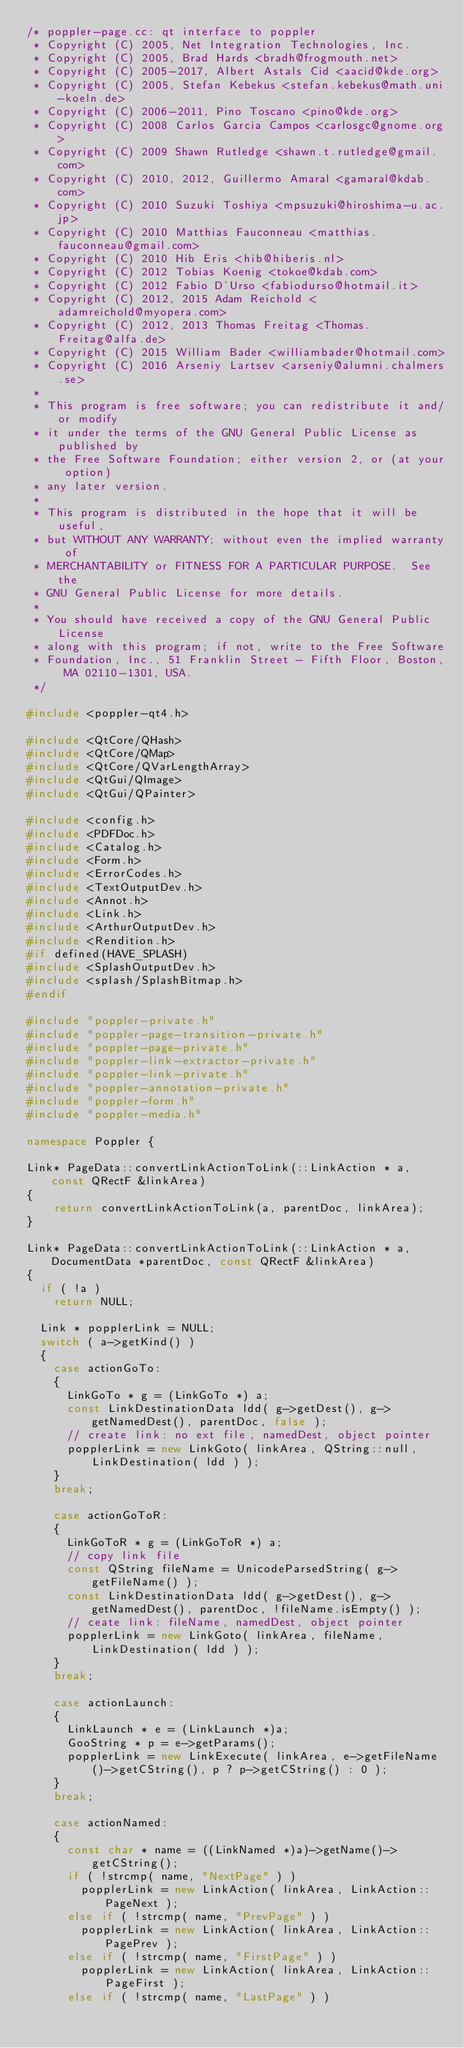Convert code to text. <code><loc_0><loc_0><loc_500><loc_500><_C++_>/* poppler-page.cc: qt interface to poppler
 * Copyright (C) 2005, Net Integration Technologies, Inc.
 * Copyright (C) 2005, Brad Hards <bradh@frogmouth.net>
 * Copyright (C) 2005-2017, Albert Astals Cid <aacid@kde.org>
 * Copyright (C) 2005, Stefan Kebekus <stefan.kebekus@math.uni-koeln.de>
 * Copyright (C) 2006-2011, Pino Toscano <pino@kde.org>
 * Copyright (C) 2008 Carlos Garcia Campos <carlosgc@gnome.org>
 * Copyright (C) 2009 Shawn Rutledge <shawn.t.rutledge@gmail.com>
 * Copyright (C) 2010, 2012, Guillermo Amaral <gamaral@kdab.com>
 * Copyright (C) 2010 Suzuki Toshiya <mpsuzuki@hiroshima-u.ac.jp>
 * Copyright (C) 2010 Matthias Fauconneau <matthias.fauconneau@gmail.com>
 * Copyright (C) 2010 Hib Eris <hib@hiberis.nl>
 * Copyright (C) 2012 Tobias Koenig <tokoe@kdab.com>
 * Copyright (C) 2012 Fabio D'Urso <fabiodurso@hotmail.it>
 * Copyright (C) 2012, 2015 Adam Reichold <adamreichold@myopera.com>
 * Copyright (C) 2012, 2013 Thomas Freitag <Thomas.Freitag@alfa.de>
 * Copyright (C) 2015 William Bader <williambader@hotmail.com>
 * Copyright (C) 2016 Arseniy Lartsev <arseniy@alumni.chalmers.se>
 *
 * This program is free software; you can redistribute it and/or modify
 * it under the terms of the GNU General Public License as published by
 * the Free Software Foundation; either version 2, or (at your option)
 * any later version.
 *
 * This program is distributed in the hope that it will be useful,
 * but WITHOUT ANY WARRANTY; without even the implied warranty of
 * MERCHANTABILITY or FITNESS FOR A PARTICULAR PURPOSE.  See the
 * GNU General Public License for more details.
 *
 * You should have received a copy of the GNU General Public License
 * along with this program; if not, write to the Free Software
 * Foundation, Inc., 51 Franklin Street - Fifth Floor, Boston, MA 02110-1301, USA.
 */

#include <poppler-qt4.h>

#include <QtCore/QHash>
#include <QtCore/QMap>
#include <QtCore/QVarLengthArray>
#include <QtGui/QImage>
#include <QtGui/QPainter>

#include <config.h>
#include <PDFDoc.h>
#include <Catalog.h>
#include <Form.h>
#include <ErrorCodes.h>
#include <TextOutputDev.h>
#include <Annot.h>
#include <Link.h>
#include <ArthurOutputDev.h>
#include <Rendition.h>
#if defined(HAVE_SPLASH)
#include <SplashOutputDev.h>
#include <splash/SplashBitmap.h>
#endif

#include "poppler-private.h"
#include "poppler-page-transition-private.h"
#include "poppler-page-private.h"
#include "poppler-link-extractor-private.h"
#include "poppler-link-private.h"
#include "poppler-annotation-private.h"
#include "poppler-form.h"
#include "poppler-media.h"

namespace Poppler {

Link* PageData::convertLinkActionToLink(::LinkAction * a, const QRectF &linkArea)
{
    return convertLinkActionToLink(a, parentDoc, linkArea);
}

Link* PageData::convertLinkActionToLink(::LinkAction * a, DocumentData *parentDoc, const QRectF &linkArea)
{
  if ( !a )
    return NULL;

  Link * popplerLink = NULL;
  switch ( a->getKind() )
  {
    case actionGoTo:
    {
      LinkGoTo * g = (LinkGoTo *) a;
      const LinkDestinationData ldd( g->getDest(), g->getNamedDest(), parentDoc, false );
      // create link: no ext file, namedDest, object pointer
      popplerLink = new LinkGoto( linkArea, QString::null, LinkDestination( ldd ) );
    }
    break;

    case actionGoToR:
    {
      LinkGoToR * g = (LinkGoToR *) a;
      // copy link file
      const QString fileName = UnicodeParsedString( g->getFileName() );
      const LinkDestinationData ldd( g->getDest(), g->getNamedDest(), parentDoc, !fileName.isEmpty() );
      // ceate link: fileName, namedDest, object pointer
      popplerLink = new LinkGoto( linkArea, fileName, LinkDestination( ldd ) );
    }
    break;

    case actionLaunch:
    {
      LinkLaunch * e = (LinkLaunch *)a;
      GooString * p = e->getParams();
      popplerLink = new LinkExecute( linkArea, e->getFileName()->getCString(), p ? p->getCString() : 0 );
    }
    break;

    case actionNamed:
    {
      const char * name = ((LinkNamed *)a)->getName()->getCString();
      if ( !strcmp( name, "NextPage" ) )
        popplerLink = new LinkAction( linkArea, LinkAction::PageNext );
      else if ( !strcmp( name, "PrevPage" ) )
        popplerLink = new LinkAction( linkArea, LinkAction::PagePrev );
      else if ( !strcmp( name, "FirstPage" ) )
        popplerLink = new LinkAction( linkArea, LinkAction::PageFirst );
      else if ( !strcmp( name, "LastPage" ) )</code> 